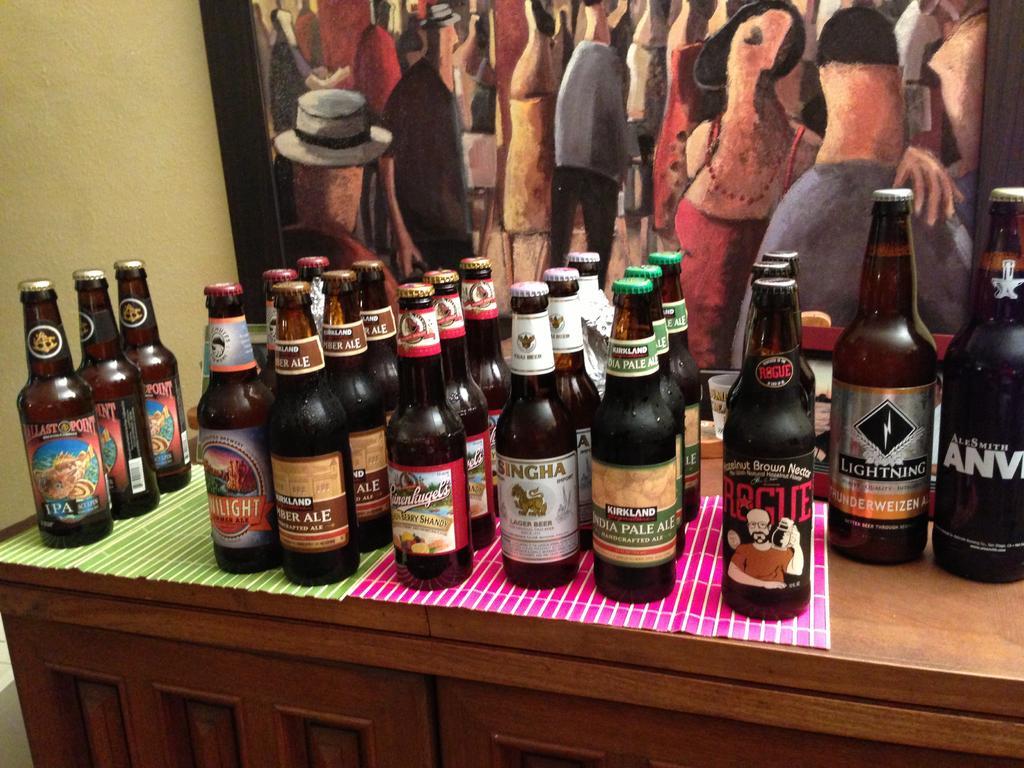Describe this image in one or two sentences. There are some beer bottles placed in rows on a table. There is a painting behind the bottles. 